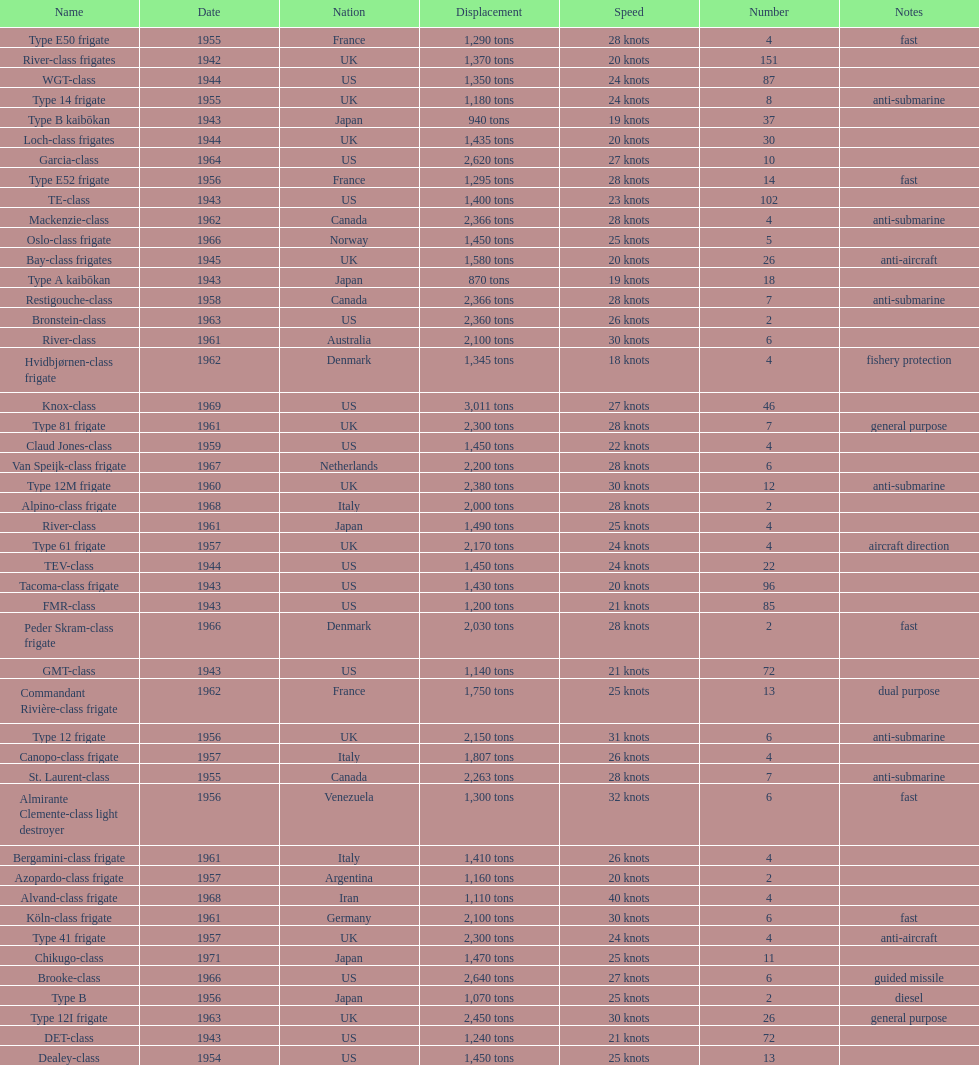In 1968 italy used alpino-class frigate. what was its top speed? 28 knots. 